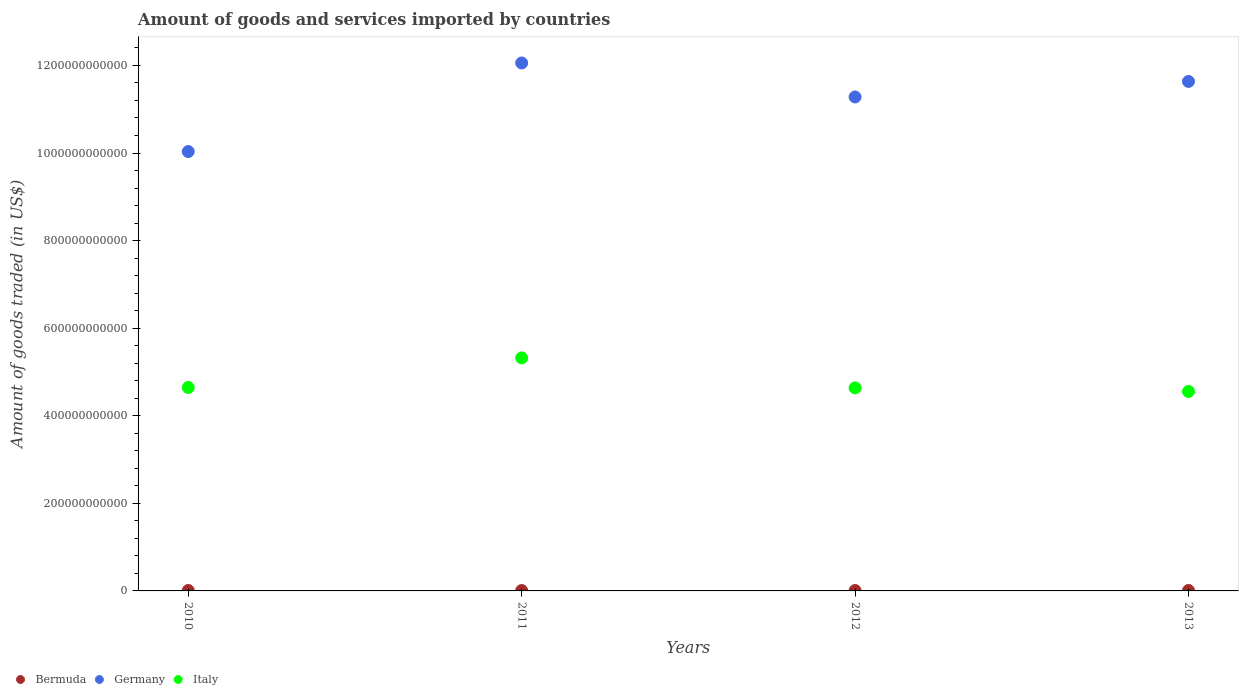How many different coloured dotlines are there?
Your answer should be very brief. 3. What is the total amount of goods and services imported in Bermuda in 2011?
Your answer should be compact. 9.00e+08. Across all years, what is the maximum total amount of goods and services imported in Italy?
Provide a short and direct response. 5.32e+11. Across all years, what is the minimum total amount of goods and services imported in Bermuda?
Ensure brevity in your answer.  9.00e+08. In which year was the total amount of goods and services imported in Italy maximum?
Make the answer very short. 2011. In which year was the total amount of goods and services imported in Italy minimum?
Make the answer very short. 2013. What is the total total amount of goods and services imported in Italy in the graph?
Make the answer very short. 1.92e+12. What is the difference between the total amount of goods and services imported in Bermuda in 2012 and that in 2013?
Your answer should be very brief. -1.11e+08. What is the difference between the total amount of goods and services imported in Germany in 2011 and the total amount of goods and services imported in Italy in 2013?
Your answer should be compact. 7.50e+11. What is the average total amount of goods and services imported in Bermuda per year?
Offer a terse response. 9.50e+08. In the year 2011, what is the difference between the total amount of goods and services imported in Germany and total amount of goods and services imported in Italy?
Offer a very short reply. 6.74e+11. In how many years, is the total amount of goods and services imported in Italy greater than 560000000000 US$?
Provide a succinct answer. 0. What is the ratio of the total amount of goods and services imported in Italy in 2011 to that in 2013?
Keep it short and to the point. 1.17. Is the difference between the total amount of goods and services imported in Germany in 2010 and 2012 greater than the difference between the total amount of goods and services imported in Italy in 2010 and 2012?
Ensure brevity in your answer.  No. What is the difference between the highest and the second highest total amount of goods and services imported in Bermuda?
Provide a succinct answer. 2.35e+07. What is the difference between the highest and the lowest total amount of goods and services imported in Italy?
Your response must be concise. 7.67e+1. Is the sum of the total amount of goods and services imported in Bermuda in 2011 and 2013 greater than the maximum total amount of goods and services imported in Italy across all years?
Provide a short and direct response. No. Is it the case that in every year, the sum of the total amount of goods and services imported in Italy and total amount of goods and services imported in Germany  is greater than the total amount of goods and services imported in Bermuda?
Provide a succinct answer. Yes. Is the total amount of goods and services imported in Italy strictly greater than the total amount of goods and services imported in Germany over the years?
Keep it short and to the point. No. Is the total amount of goods and services imported in Bermuda strictly less than the total amount of goods and services imported in Germany over the years?
Provide a short and direct response. Yes. How many years are there in the graph?
Keep it short and to the point. 4. What is the difference between two consecutive major ticks on the Y-axis?
Make the answer very short. 2.00e+11. Does the graph contain grids?
Ensure brevity in your answer.  No. How many legend labels are there?
Offer a very short reply. 3. What is the title of the graph?
Offer a terse response. Amount of goods and services imported by countries. Does "Jamaica" appear as one of the legend labels in the graph?
Your answer should be very brief. No. What is the label or title of the X-axis?
Keep it short and to the point. Years. What is the label or title of the Y-axis?
Your answer should be very brief. Amount of goods traded (in US$). What is the Amount of goods traded (in US$) of Bermuda in 2010?
Provide a short and direct response. 9.88e+08. What is the Amount of goods traded (in US$) in Germany in 2010?
Your answer should be compact. 1.00e+12. What is the Amount of goods traded (in US$) in Italy in 2010?
Offer a terse response. 4.65e+11. What is the Amount of goods traded (in US$) of Bermuda in 2011?
Ensure brevity in your answer.  9.00e+08. What is the Amount of goods traded (in US$) in Germany in 2011?
Your response must be concise. 1.21e+12. What is the Amount of goods traded (in US$) in Italy in 2011?
Offer a very short reply. 5.32e+11. What is the Amount of goods traded (in US$) of Bermuda in 2012?
Your response must be concise. 9.00e+08. What is the Amount of goods traded (in US$) of Germany in 2012?
Ensure brevity in your answer.  1.13e+12. What is the Amount of goods traded (in US$) in Italy in 2012?
Your answer should be very brief. 4.64e+11. What is the Amount of goods traded (in US$) in Bermuda in 2013?
Your answer should be very brief. 1.01e+09. What is the Amount of goods traded (in US$) in Germany in 2013?
Offer a very short reply. 1.16e+12. What is the Amount of goods traded (in US$) of Italy in 2013?
Give a very brief answer. 4.55e+11. Across all years, what is the maximum Amount of goods traded (in US$) of Bermuda?
Your answer should be compact. 1.01e+09. Across all years, what is the maximum Amount of goods traded (in US$) in Germany?
Ensure brevity in your answer.  1.21e+12. Across all years, what is the maximum Amount of goods traded (in US$) in Italy?
Your answer should be compact. 5.32e+11. Across all years, what is the minimum Amount of goods traded (in US$) in Bermuda?
Give a very brief answer. 9.00e+08. Across all years, what is the minimum Amount of goods traded (in US$) of Germany?
Your response must be concise. 1.00e+12. Across all years, what is the minimum Amount of goods traded (in US$) in Italy?
Keep it short and to the point. 4.55e+11. What is the total Amount of goods traded (in US$) of Bermuda in the graph?
Ensure brevity in your answer.  3.80e+09. What is the total Amount of goods traded (in US$) in Germany in the graph?
Give a very brief answer. 4.50e+12. What is the total Amount of goods traded (in US$) of Italy in the graph?
Your answer should be very brief. 1.92e+12. What is the difference between the Amount of goods traded (in US$) in Bermuda in 2010 and that in 2011?
Offer a terse response. 8.76e+07. What is the difference between the Amount of goods traded (in US$) of Germany in 2010 and that in 2011?
Provide a succinct answer. -2.02e+11. What is the difference between the Amount of goods traded (in US$) of Italy in 2010 and that in 2011?
Offer a very short reply. -6.76e+1. What is the difference between the Amount of goods traded (in US$) of Bermuda in 2010 and that in 2012?
Your response must be concise. 8.77e+07. What is the difference between the Amount of goods traded (in US$) in Germany in 2010 and that in 2012?
Ensure brevity in your answer.  -1.25e+11. What is the difference between the Amount of goods traded (in US$) in Italy in 2010 and that in 2012?
Your answer should be very brief. 8.82e+08. What is the difference between the Amount of goods traded (in US$) in Bermuda in 2010 and that in 2013?
Give a very brief answer. -2.35e+07. What is the difference between the Amount of goods traded (in US$) of Germany in 2010 and that in 2013?
Offer a very short reply. -1.60e+11. What is the difference between the Amount of goods traded (in US$) of Italy in 2010 and that in 2013?
Provide a succinct answer. 9.10e+09. What is the difference between the Amount of goods traded (in US$) in Bermuda in 2011 and that in 2012?
Ensure brevity in your answer.  5.14e+04. What is the difference between the Amount of goods traded (in US$) in Germany in 2011 and that in 2012?
Offer a terse response. 7.77e+1. What is the difference between the Amount of goods traded (in US$) in Italy in 2011 and that in 2012?
Keep it short and to the point. 6.85e+1. What is the difference between the Amount of goods traded (in US$) in Bermuda in 2011 and that in 2013?
Provide a short and direct response. -1.11e+08. What is the difference between the Amount of goods traded (in US$) in Germany in 2011 and that in 2013?
Offer a very short reply. 4.22e+1. What is the difference between the Amount of goods traded (in US$) in Italy in 2011 and that in 2013?
Provide a succinct answer. 7.67e+1. What is the difference between the Amount of goods traded (in US$) in Bermuda in 2012 and that in 2013?
Offer a terse response. -1.11e+08. What is the difference between the Amount of goods traded (in US$) of Germany in 2012 and that in 2013?
Provide a short and direct response. -3.54e+1. What is the difference between the Amount of goods traded (in US$) of Italy in 2012 and that in 2013?
Provide a succinct answer. 8.22e+09. What is the difference between the Amount of goods traded (in US$) of Bermuda in 2010 and the Amount of goods traded (in US$) of Germany in 2011?
Keep it short and to the point. -1.20e+12. What is the difference between the Amount of goods traded (in US$) of Bermuda in 2010 and the Amount of goods traded (in US$) of Italy in 2011?
Give a very brief answer. -5.31e+11. What is the difference between the Amount of goods traded (in US$) in Germany in 2010 and the Amount of goods traded (in US$) in Italy in 2011?
Provide a succinct answer. 4.71e+11. What is the difference between the Amount of goods traded (in US$) of Bermuda in 2010 and the Amount of goods traded (in US$) of Germany in 2012?
Your answer should be very brief. -1.13e+12. What is the difference between the Amount of goods traded (in US$) of Bermuda in 2010 and the Amount of goods traded (in US$) of Italy in 2012?
Provide a short and direct response. -4.63e+11. What is the difference between the Amount of goods traded (in US$) of Germany in 2010 and the Amount of goods traded (in US$) of Italy in 2012?
Give a very brief answer. 5.40e+11. What is the difference between the Amount of goods traded (in US$) in Bermuda in 2010 and the Amount of goods traded (in US$) in Germany in 2013?
Give a very brief answer. -1.16e+12. What is the difference between the Amount of goods traded (in US$) of Bermuda in 2010 and the Amount of goods traded (in US$) of Italy in 2013?
Give a very brief answer. -4.54e+11. What is the difference between the Amount of goods traded (in US$) of Germany in 2010 and the Amount of goods traded (in US$) of Italy in 2013?
Offer a very short reply. 5.48e+11. What is the difference between the Amount of goods traded (in US$) in Bermuda in 2011 and the Amount of goods traded (in US$) in Germany in 2012?
Offer a very short reply. -1.13e+12. What is the difference between the Amount of goods traded (in US$) of Bermuda in 2011 and the Amount of goods traded (in US$) of Italy in 2012?
Your response must be concise. -4.63e+11. What is the difference between the Amount of goods traded (in US$) in Germany in 2011 and the Amount of goods traded (in US$) in Italy in 2012?
Your answer should be very brief. 7.42e+11. What is the difference between the Amount of goods traded (in US$) in Bermuda in 2011 and the Amount of goods traded (in US$) in Germany in 2013?
Keep it short and to the point. -1.16e+12. What is the difference between the Amount of goods traded (in US$) in Bermuda in 2011 and the Amount of goods traded (in US$) in Italy in 2013?
Provide a short and direct response. -4.55e+11. What is the difference between the Amount of goods traded (in US$) of Germany in 2011 and the Amount of goods traded (in US$) of Italy in 2013?
Give a very brief answer. 7.50e+11. What is the difference between the Amount of goods traded (in US$) in Bermuda in 2012 and the Amount of goods traded (in US$) in Germany in 2013?
Your answer should be very brief. -1.16e+12. What is the difference between the Amount of goods traded (in US$) of Bermuda in 2012 and the Amount of goods traded (in US$) of Italy in 2013?
Give a very brief answer. -4.55e+11. What is the difference between the Amount of goods traded (in US$) in Germany in 2012 and the Amount of goods traded (in US$) in Italy in 2013?
Offer a very short reply. 6.73e+11. What is the average Amount of goods traded (in US$) in Bermuda per year?
Keep it short and to the point. 9.50e+08. What is the average Amount of goods traded (in US$) of Germany per year?
Offer a very short reply. 1.13e+12. What is the average Amount of goods traded (in US$) in Italy per year?
Keep it short and to the point. 4.79e+11. In the year 2010, what is the difference between the Amount of goods traded (in US$) of Bermuda and Amount of goods traded (in US$) of Germany?
Make the answer very short. -1.00e+12. In the year 2010, what is the difference between the Amount of goods traded (in US$) in Bermuda and Amount of goods traded (in US$) in Italy?
Keep it short and to the point. -4.64e+11. In the year 2010, what is the difference between the Amount of goods traded (in US$) of Germany and Amount of goods traded (in US$) of Italy?
Give a very brief answer. 5.39e+11. In the year 2011, what is the difference between the Amount of goods traded (in US$) in Bermuda and Amount of goods traded (in US$) in Germany?
Provide a succinct answer. -1.20e+12. In the year 2011, what is the difference between the Amount of goods traded (in US$) in Bermuda and Amount of goods traded (in US$) in Italy?
Your answer should be compact. -5.31e+11. In the year 2011, what is the difference between the Amount of goods traded (in US$) in Germany and Amount of goods traded (in US$) in Italy?
Your response must be concise. 6.74e+11. In the year 2012, what is the difference between the Amount of goods traded (in US$) in Bermuda and Amount of goods traded (in US$) in Germany?
Offer a terse response. -1.13e+12. In the year 2012, what is the difference between the Amount of goods traded (in US$) in Bermuda and Amount of goods traded (in US$) in Italy?
Provide a succinct answer. -4.63e+11. In the year 2012, what is the difference between the Amount of goods traded (in US$) in Germany and Amount of goods traded (in US$) in Italy?
Give a very brief answer. 6.64e+11. In the year 2013, what is the difference between the Amount of goods traded (in US$) of Bermuda and Amount of goods traded (in US$) of Germany?
Make the answer very short. -1.16e+12. In the year 2013, what is the difference between the Amount of goods traded (in US$) in Bermuda and Amount of goods traded (in US$) in Italy?
Provide a short and direct response. -4.54e+11. In the year 2013, what is the difference between the Amount of goods traded (in US$) in Germany and Amount of goods traded (in US$) in Italy?
Provide a short and direct response. 7.08e+11. What is the ratio of the Amount of goods traded (in US$) in Bermuda in 2010 to that in 2011?
Provide a short and direct response. 1.1. What is the ratio of the Amount of goods traded (in US$) in Germany in 2010 to that in 2011?
Offer a very short reply. 0.83. What is the ratio of the Amount of goods traded (in US$) of Italy in 2010 to that in 2011?
Offer a terse response. 0.87. What is the ratio of the Amount of goods traded (in US$) of Bermuda in 2010 to that in 2012?
Offer a terse response. 1.1. What is the ratio of the Amount of goods traded (in US$) of Germany in 2010 to that in 2012?
Provide a short and direct response. 0.89. What is the ratio of the Amount of goods traded (in US$) in Italy in 2010 to that in 2012?
Your answer should be very brief. 1. What is the ratio of the Amount of goods traded (in US$) in Bermuda in 2010 to that in 2013?
Give a very brief answer. 0.98. What is the ratio of the Amount of goods traded (in US$) of Germany in 2010 to that in 2013?
Your answer should be compact. 0.86. What is the ratio of the Amount of goods traded (in US$) in Bermuda in 2011 to that in 2012?
Your answer should be very brief. 1. What is the ratio of the Amount of goods traded (in US$) in Germany in 2011 to that in 2012?
Provide a succinct answer. 1.07. What is the ratio of the Amount of goods traded (in US$) in Italy in 2011 to that in 2012?
Keep it short and to the point. 1.15. What is the ratio of the Amount of goods traded (in US$) of Bermuda in 2011 to that in 2013?
Give a very brief answer. 0.89. What is the ratio of the Amount of goods traded (in US$) in Germany in 2011 to that in 2013?
Provide a succinct answer. 1.04. What is the ratio of the Amount of goods traded (in US$) of Italy in 2011 to that in 2013?
Ensure brevity in your answer.  1.17. What is the ratio of the Amount of goods traded (in US$) in Bermuda in 2012 to that in 2013?
Keep it short and to the point. 0.89. What is the ratio of the Amount of goods traded (in US$) of Germany in 2012 to that in 2013?
Provide a succinct answer. 0.97. What is the difference between the highest and the second highest Amount of goods traded (in US$) of Bermuda?
Offer a terse response. 2.35e+07. What is the difference between the highest and the second highest Amount of goods traded (in US$) of Germany?
Keep it short and to the point. 4.22e+1. What is the difference between the highest and the second highest Amount of goods traded (in US$) in Italy?
Provide a short and direct response. 6.76e+1. What is the difference between the highest and the lowest Amount of goods traded (in US$) in Bermuda?
Provide a short and direct response. 1.11e+08. What is the difference between the highest and the lowest Amount of goods traded (in US$) in Germany?
Give a very brief answer. 2.02e+11. What is the difference between the highest and the lowest Amount of goods traded (in US$) in Italy?
Offer a very short reply. 7.67e+1. 